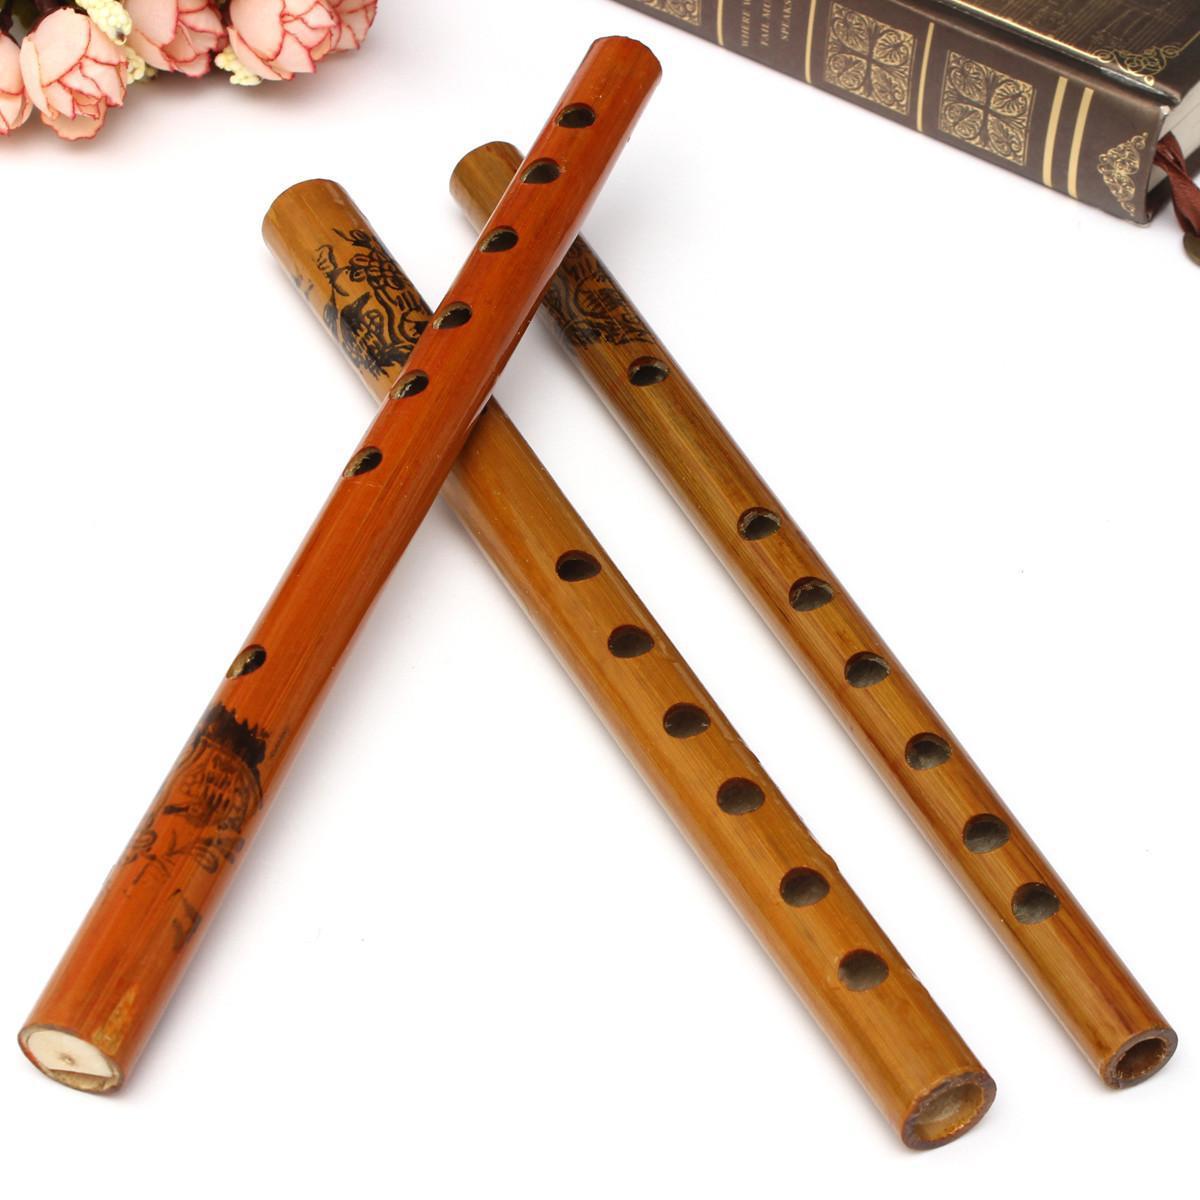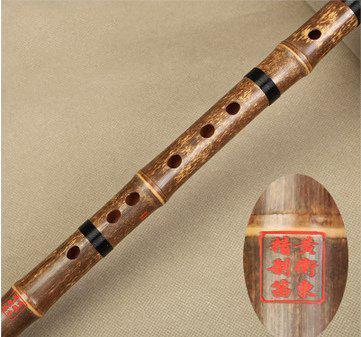The first image is the image on the left, the second image is the image on the right. Examine the images to the left and right. Is the description "There are exactly two flutes." accurate? Answer yes or no. No. The first image is the image on the left, the second image is the image on the right. Analyze the images presented: Is the assertion "At least 2 flutes are laying on a wood plank table." valid? Answer yes or no. No. 